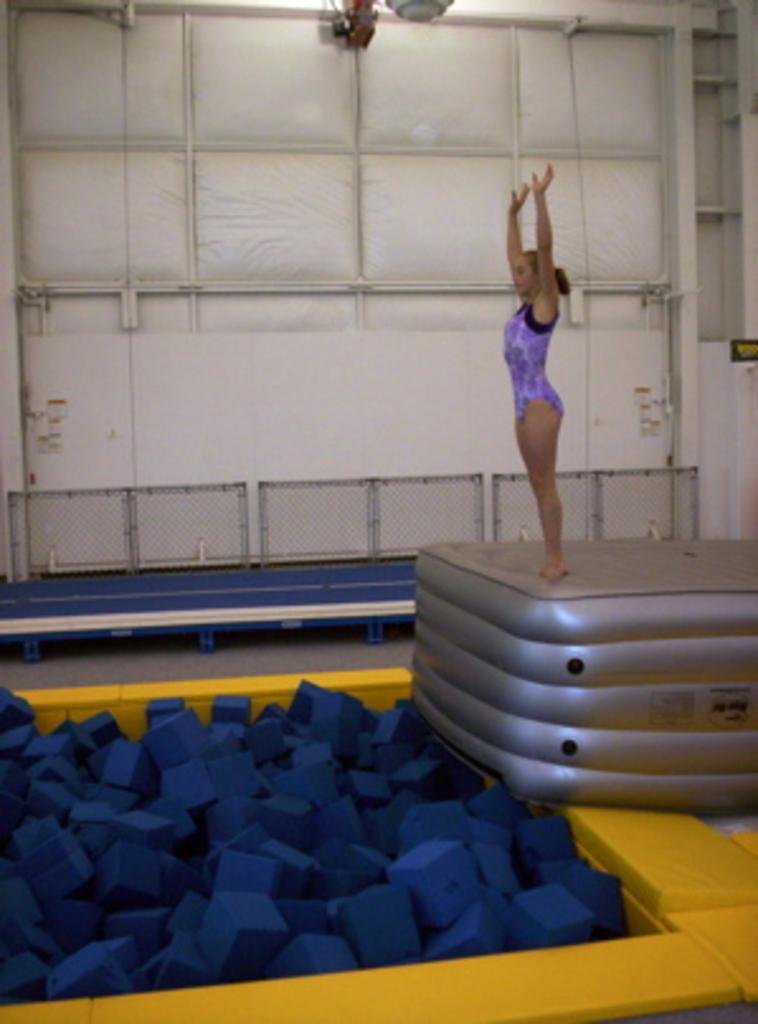In one or two sentences, can you explain what this image depicts? This picture shows a man standing on the air bed by raising her hands up. 